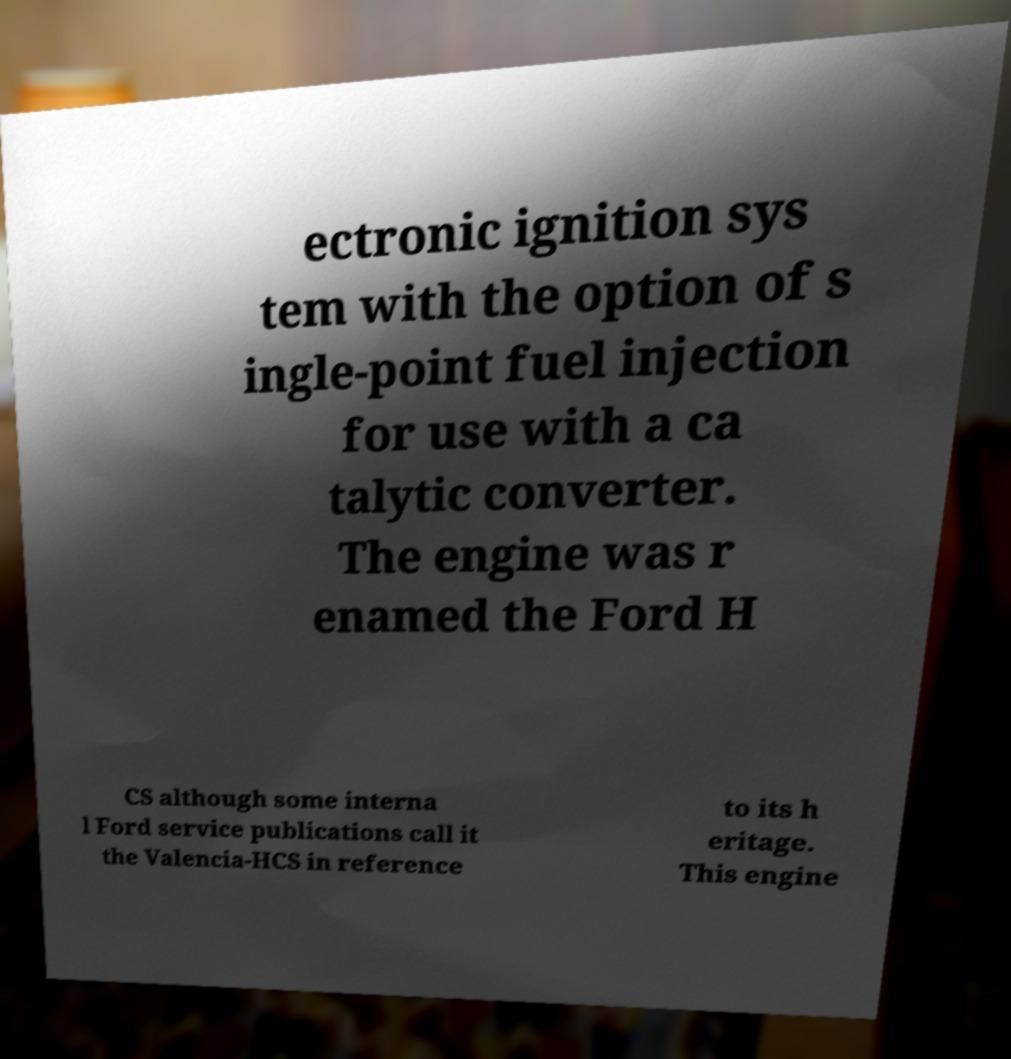Could you extract and type out the text from this image? ectronic ignition sys tem with the option of s ingle-point fuel injection for use with a ca talytic converter. The engine was r enamed the Ford H CS although some interna l Ford service publications call it the Valencia-HCS in reference to its h eritage. This engine 